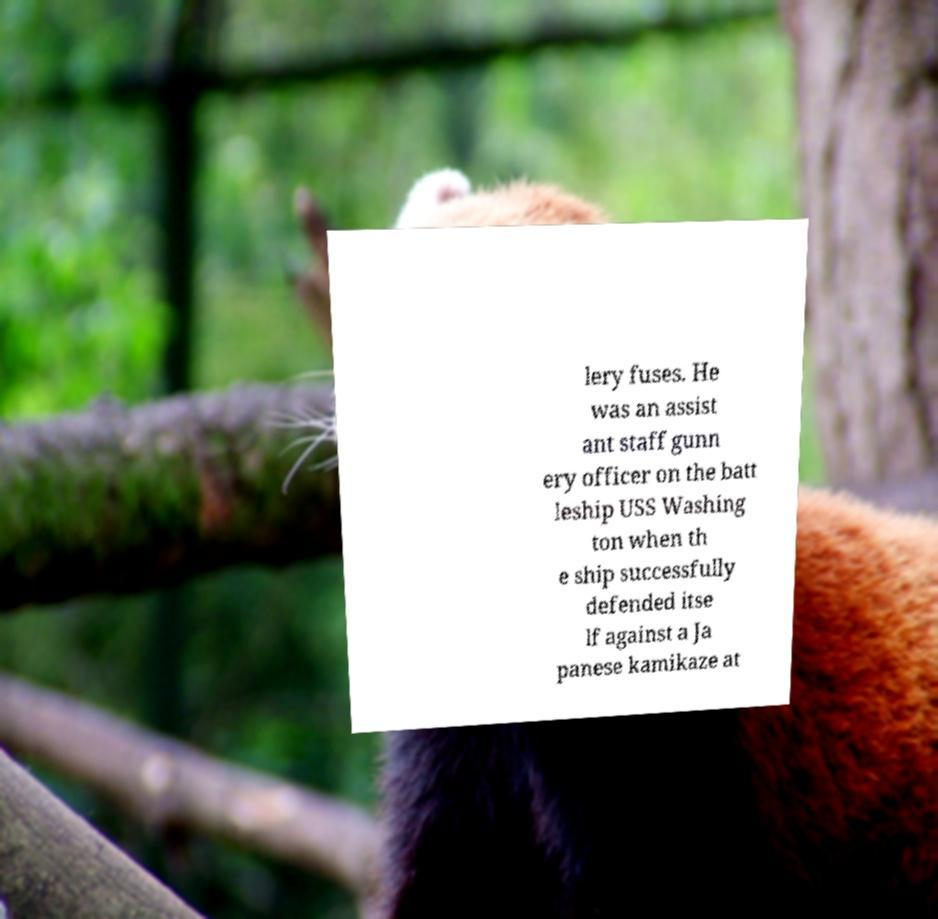What messages or text are displayed in this image? I need them in a readable, typed format. lery fuses. He was an assist ant staff gunn ery officer on the batt leship USS Washing ton when th e ship successfully defended itse lf against a Ja panese kamikaze at 